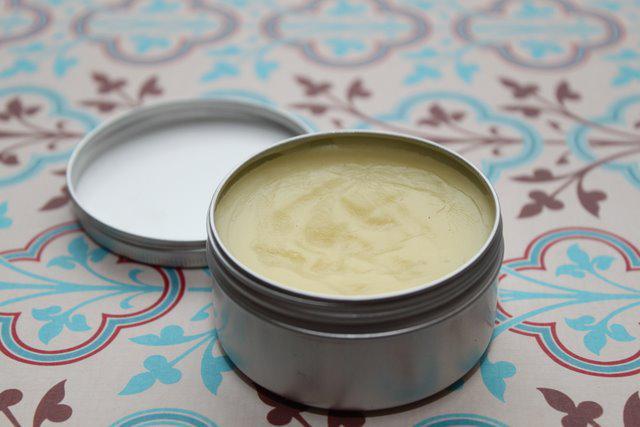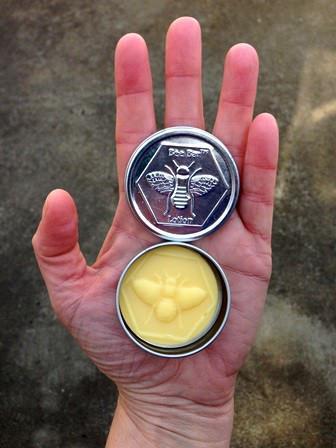The first image is the image on the left, the second image is the image on the right. Considering the images on both sides, is "A circular bar of soap has a bee imprinted on it." valid? Answer yes or no. Yes. 